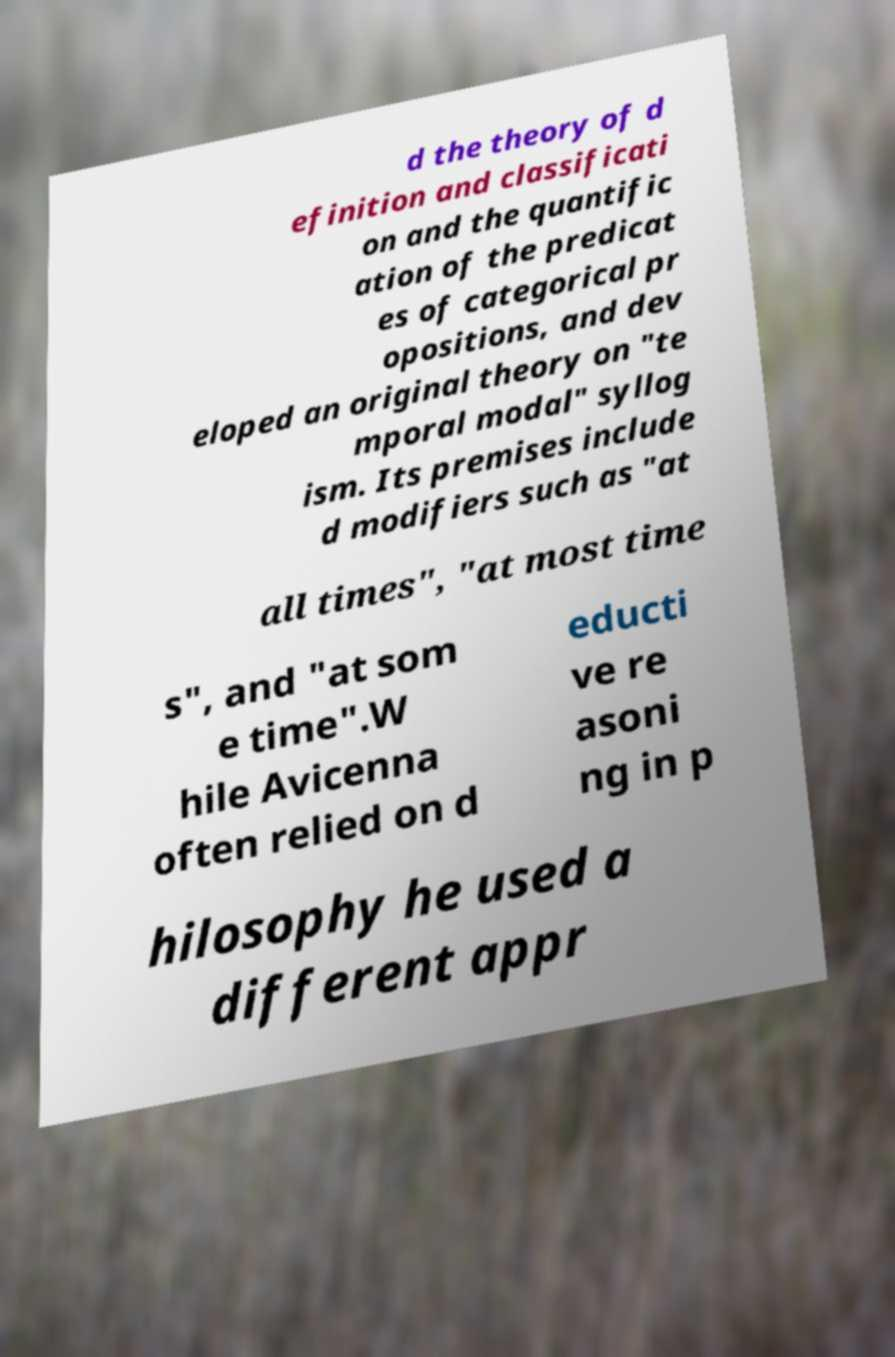Please identify and transcribe the text found in this image. d the theory of d efinition and classificati on and the quantific ation of the predicat es of categorical pr opositions, and dev eloped an original theory on "te mporal modal" syllog ism. Its premises include d modifiers such as "at all times", "at most time s", and "at som e time".W hile Avicenna often relied on d educti ve re asoni ng in p hilosophy he used a different appr 